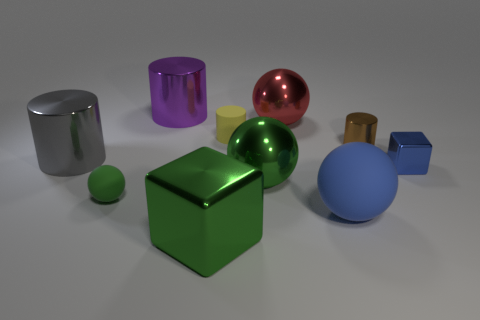What kind of material do the objects look like they're made of? The objects in the image appear to be made of various materials based on their surface textures and reflections. The spheres and the cube in the foreground, especially the green sphere and the metallic cube, have a high-gloss finish suggesting a smooth and reflective material such as polished metal or plastic. The purple and gold cylinders have a slightly matte finish suggesting a less reflective material, and the blue sphere has a completely matte finish, which could indicate a more diffuse material like rubber or matte painted metal. 